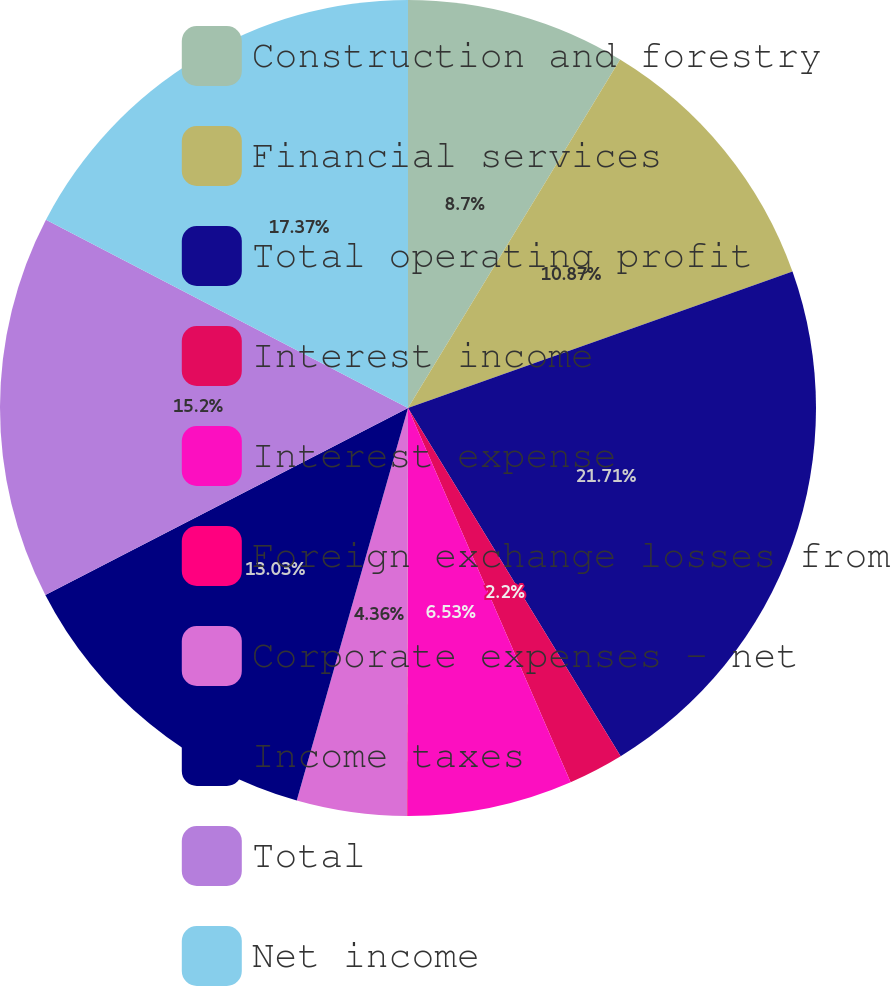Convert chart to OTSL. <chart><loc_0><loc_0><loc_500><loc_500><pie_chart><fcel>Construction and forestry<fcel>Financial services<fcel>Total operating profit<fcel>Interest income<fcel>Interest expense<fcel>Foreign exchange losses from<fcel>Corporate expenses - net<fcel>Income taxes<fcel>Total<fcel>Net income<nl><fcel>8.7%<fcel>10.87%<fcel>21.7%<fcel>2.2%<fcel>6.53%<fcel>0.03%<fcel>4.36%<fcel>13.03%<fcel>15.2%<fcel>17.37%<nl></chart> 